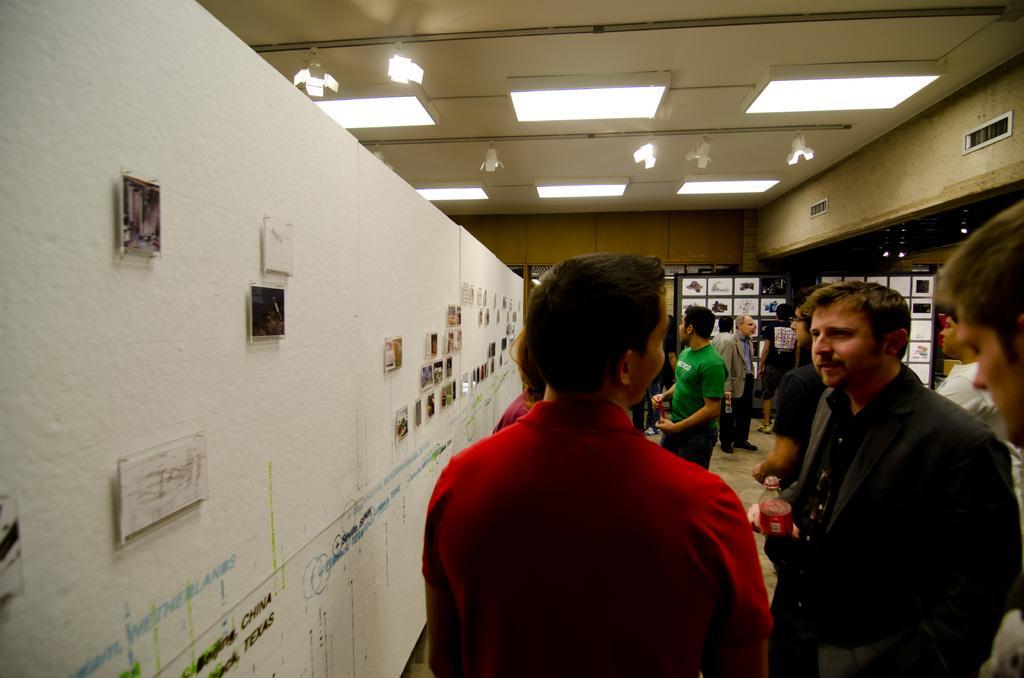Describe this image in one or two sentences. In this image there are people. The man standing on the right is holding a bottle. On the left there is a wall and we can see frames placed on the wall. In the background there are shelves. At the top there are lights. 